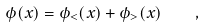Convert formula to latex. <formula><loc_0><loc_0><loc_500><loc_500>\phi ( x ) = \phi _ { < } ( x ) + \phi _ { > } ( x ) \quad ,</formula> 